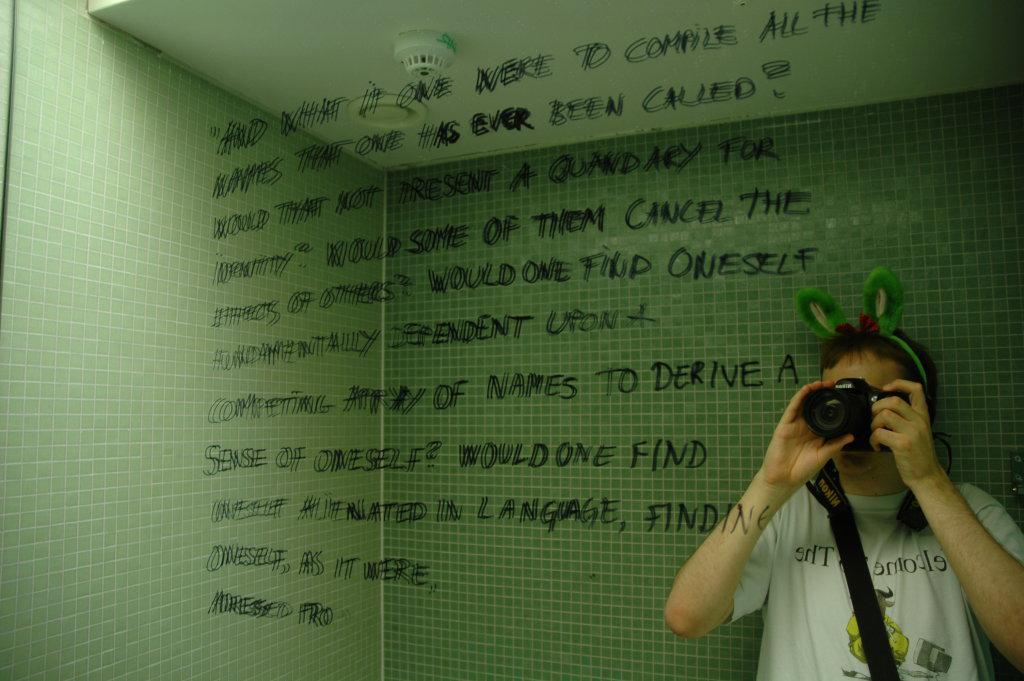What is there is a person holding a camera in the image, what might they be doing? The person holding a camera in the image might be taking a photograph or recording a video. What can be seen written on the wall in the image? There is text written on a wall in the image, but without more information, we cannot determine what it says. What color is the roof in the image? The roof in the image is white. Can you tell me how many yokes are hanging from the roof in the image? There are no yokes present in the image; it only features a person holding a camera, text on a wall, and a white roof. What grade of brain is visible in the image? There is no brain present in the image, so it is not possible to determine its grade. 